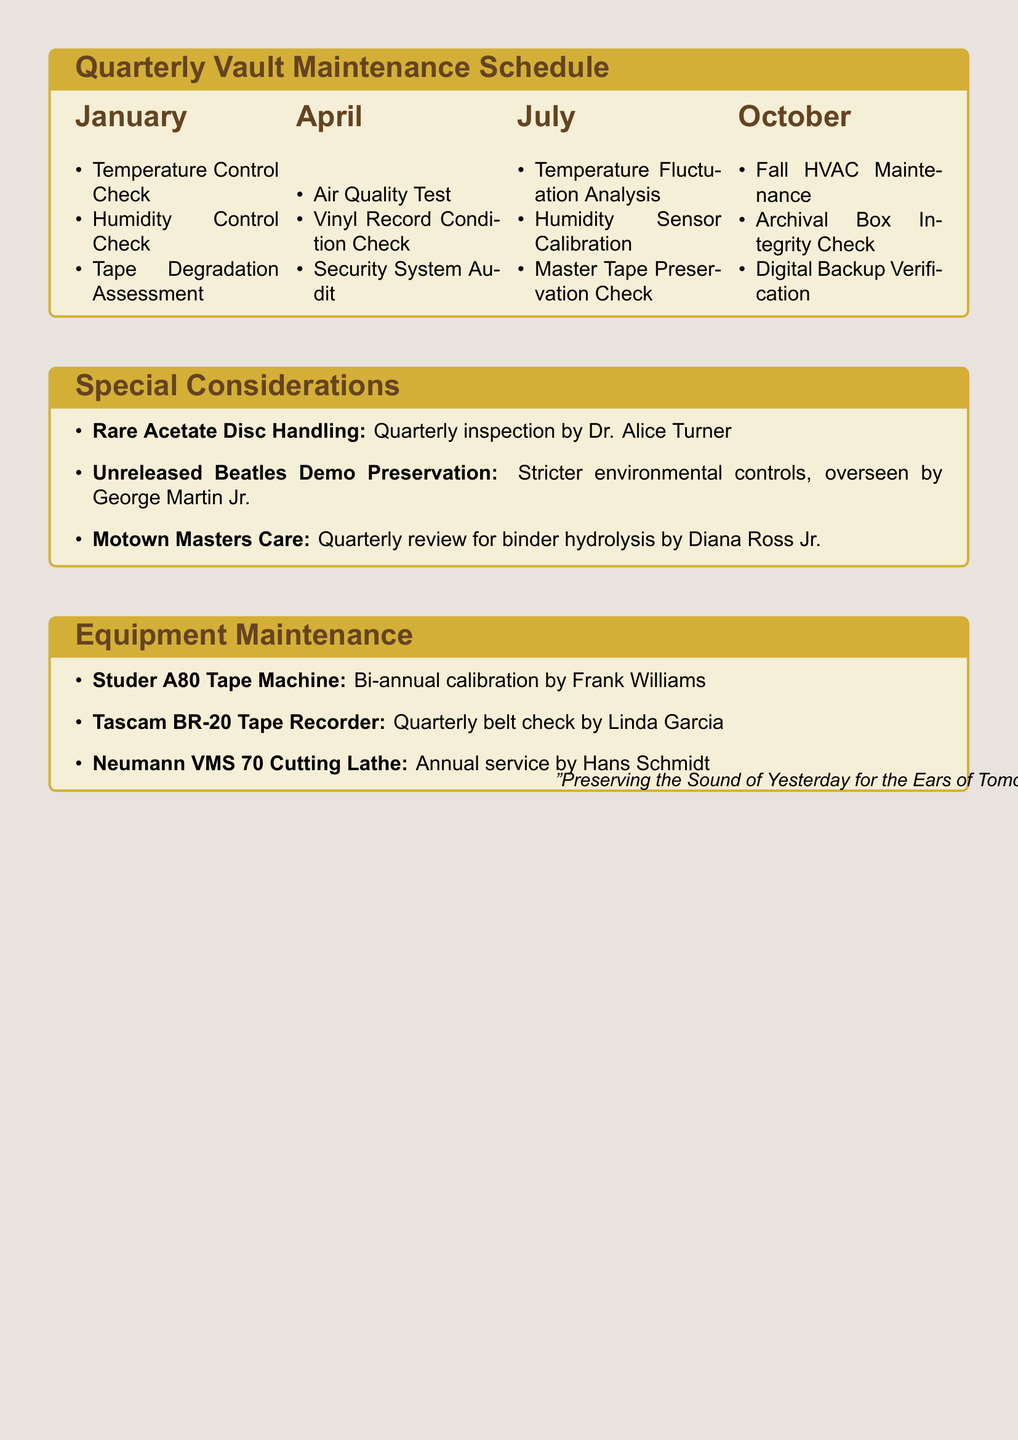What is the temperature setting for the vault? The document specifies the required temperature setting to maintain at 65°F (18°C).
Answer: 65°F (18°C) Who is responsible for the Humidity Control Check in January? The document lists Emily Johnson as the responsible person for the Humidity Control Check in January.
Answer: Emily Johnson Which month includes the Air Quality Test task? The document includes the Air Quality Test task in the April section.
Answer: April What is the main task for the July maintenance? The primary tasks in July include Temperature Fluctuation Analysis, among others.
Answer: Temperature Fluctuation Analysis Who is tasked with inspecting Motown master tapes? The document states that Diana Ross Jr. is responsible for the quarterly review of original Motown master tapes.
Answer: Diana Ross Jr What type of maintenance is scheduled for the Tascam BR-20 Tape Recorder? The Tascam BR-20 Tape Recorder requires a quarterly belt check and replacement if needed.
Answer: Quarterly belt check How often should the Studer A80 Tape Machine be calibrated? The document indicates that the Studer A80 Tape Machine requires bi-annual calibration.
Answer: Bi-annual What kind of special consideration is given to pre-1950s acetate discs? The document states there is a quarterly inspection for signs of delamination for rare acetate discs.
Answer: Quarterly inspection What is the primary function of the special considerations listed in the document? The special considerations focus on specific preservation needs for rare recordings and formats.
Answer: Preservation needs 